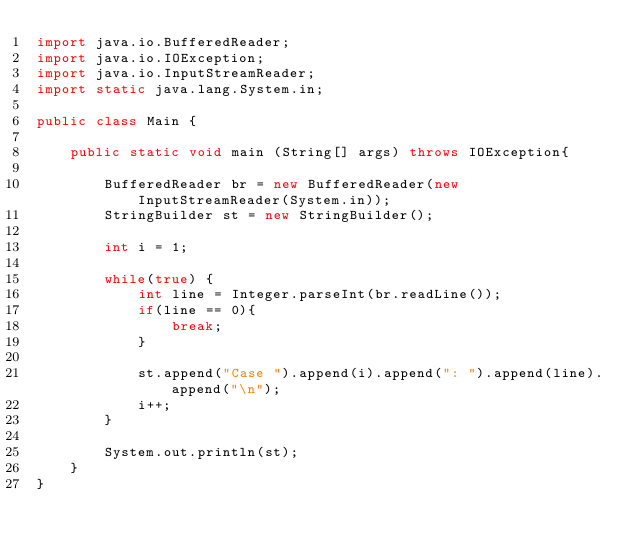<code> <loc_0><loc_0><loc_500><loc_500><_Java_>import java.io.BufferedReader;
import java.io.IOException;
import java.io.InputStreamReader;
import static java.lang.System.in;

public class Main {

    public static void main (String[] args) throws IOException{
        
        BufferedReader br = new BufferedReader(new InputStreamReader(System.in));
        StringBuilder st = new StringBuilder();
        
        int i = 1;
        
        while(true) {
            int line = Integer.parseInt(br.readLine());
            if(line == 0){
                break;
            }
            
            st.append("Case ").append(i).append(": ").append(line).append("\n");
            i++;
        }
        
        System.out.println(st);
    }
}</code> 